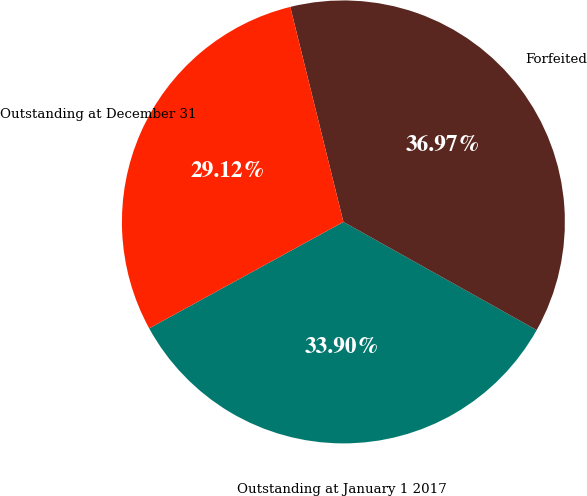Convert chart to OTSL. <chart><loc_0><loc_0><loc_500><loc_500><pie_chart><fcel>Outstanding at January 1 2017<fcel>Forfeited<fcel>Outstanding at December 31<nl><fcel>33.9%<fcel>36.97%<fcel>29.12%<nl></chart> 